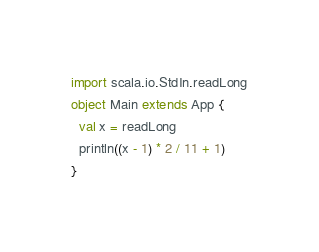Convert code to text. <code><loc_0><loc_0><loc_500><loc_500><_Scala_>import scala.io.StdIn.readLong
object Main extends App {
  val x = readLong
  println((x - 1) * 2 / 11 + 1)
}
</code> 